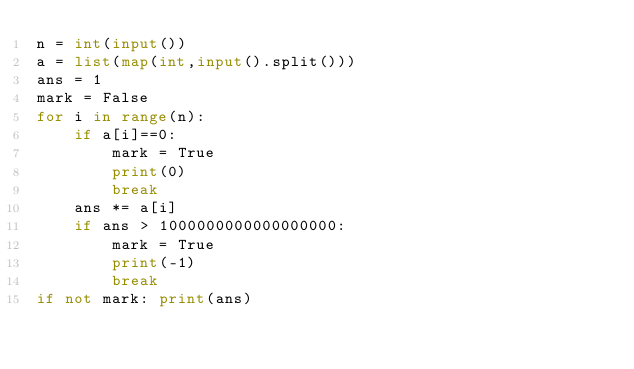<code> <loc_0><loc_0><loc_500><loc_500><_Python_>n = int(input())
a = list(map(int,input().split()))
ans = 1
mark = False
for i in range(n):
    if a[i]==0:
        mark = True
        print(0)
        break
    ans *= a[i]
    if ans > 1000000000000000000:
        mark = True
        print(-1)
        break
if not mark: print(ans)
</code> 